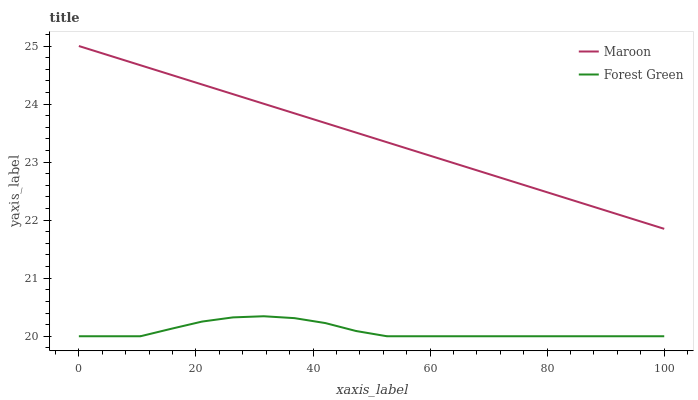Does Forest Green have the minimum area under the curve?
Answer yes or no. Yes. Does Maroon have the maximum area under the curve?
Answer yes or no. Yes. Does Maroon have the minimum area under the curve?
Answer yes or no. No. Is Maroon the smoothest?
Answer yes or no. Yes. Is Forest Green the roughest?
Answer yes or no. Yes. Is Maroon the roughest?
Answer yes or no. No. Does Forest Green have the lowest value?
Answer yes or no. Yes. Does Maroon have the lowest value?
Answer yes or no. No. Does Maroon have the highest value?
Answer yes or no. Yes. Is Forest Green less than Maroon?
Answer yes or no. Yes. Is Maroon greater than Forest Green?
Answer yes or no. Yes. Does Forest Green intersect Maroon?
Answer yes or no. No. 